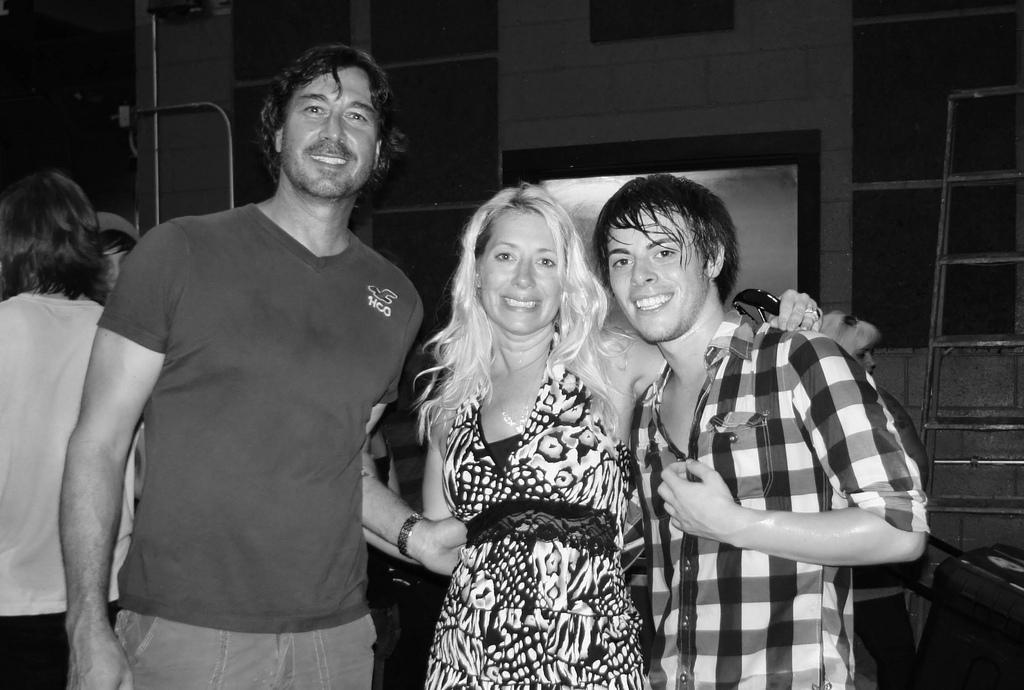What are the people in the image doing? The people in the image are standing on the ground. What can be seen in the background of the image? There is a stand and a building in the background of the image. What type of stocking is being sold at the stand in the image? There is no mention of a stocking or any item being sold at the stand in the image. 